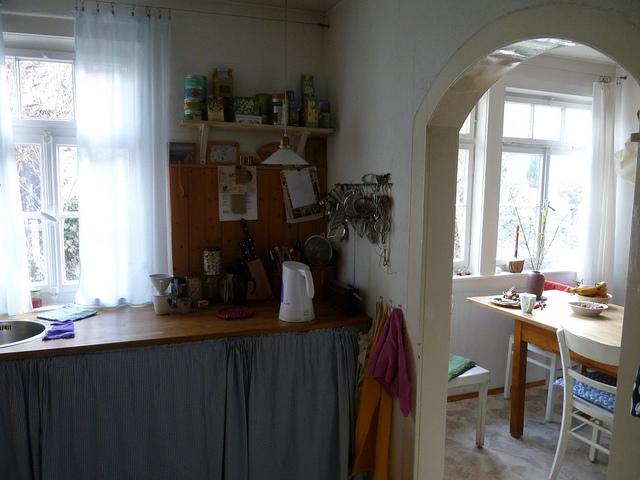Is it bright outside?
Concise answer only. Yes. Is there a sink in this room?
Be succinct. Yes. Is this natural or artificial light?
Short answer required. Natural. 